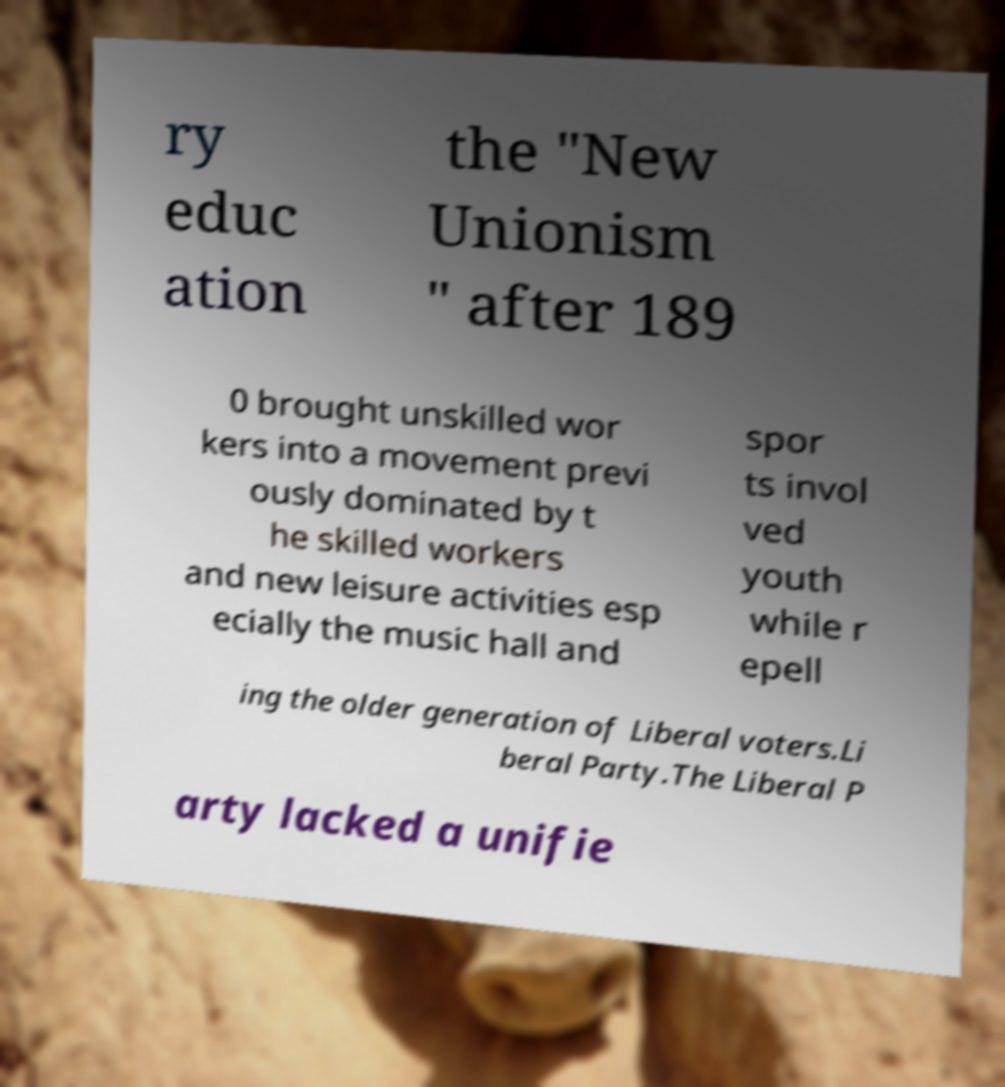Could you assist in decoding the text presented in this image and type it out clearly? ry educ ation the "New Unionism " after 189 0 brought unskilled wor kers into a movement previ ously dominated by t he skilled workers and new leisure activities esp ecially the music hall and spor ts invol ved youth while r epell ing the older generation of Liberal voters.Li beral Party.The Liberal P arty lacked a unifie 